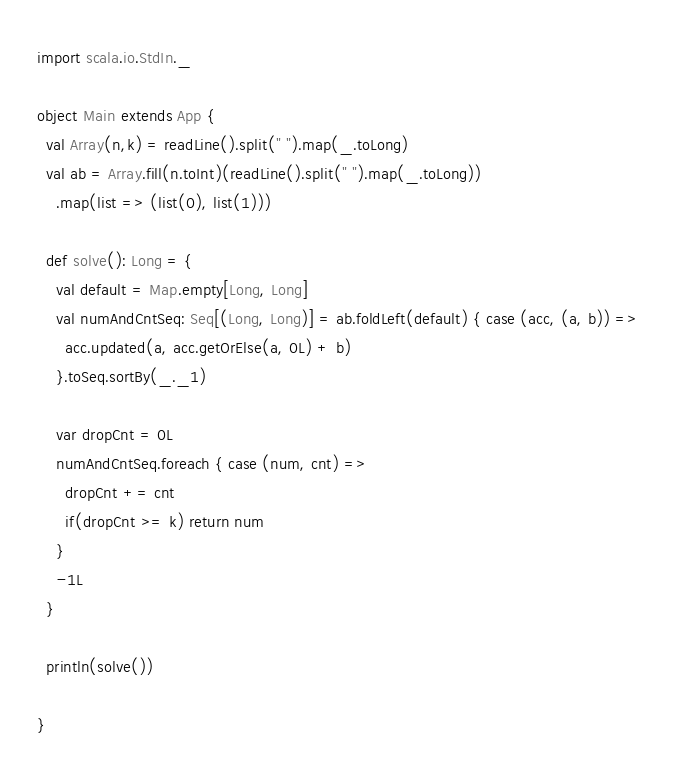Convert code to text. <code><loc_0><loc_0><loc_500><loc_500><_Scala_>import scala.io.StdIn._

object Main extends App {
  val Array(n,k) = readLine().split(" ").map(_.toLong)
  val ab = Array.fill(n.toInt)(readLine().split(" ").map(_.toLong))
    .map(list => (list(0), list(1)))

  def solve(): Long = {
    val default = Map.empty[Long, Long]
    val numAndCntSeq: Seq[(Long, Long)] = ab.foldLeft(default) { case (acc, (a, b)) =>
      acc.updated(a, acc.getOrElse(a, 0L) + b)
    }.toSeq.sortBy(_._1)

    var dropCnt = 0L
    numAndCntSeq.foreach { case (num, cnt) =>
      dropCnt += cnt
      if(dropCnt >= k) return num
    }
    -1L
  }

  println(solve())

}

</code> 